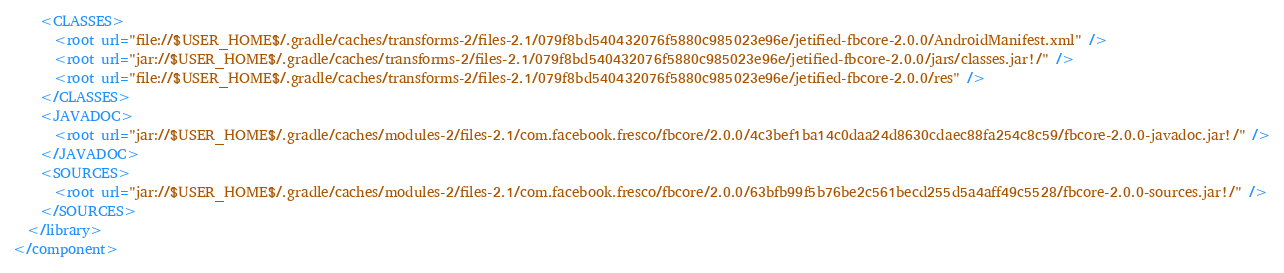Convert code to text. <code><loc_0><loc_0><loc_500><loc_500><_XML_>    <CLASSES>
      <root url="file://$USER_HOME$/.gradle/caches/transforms-2/files-2.1/079f8bd540432076f5880c985023e96e/jetified-fbcore-2.0.0/AndroidManifest.xml" />
      <root url="jar://$USER_HOME$/.gradle/caches/transforms-2/files-2.1/079f8bd540432076f5880c985023e96e/jetified-fbcore-2.0.0/jars/classes.jar!/" />
      <root url="file://$USER_HOME$/.gradle/caches/transforms-2/files-2.1/079f8bd540432076f5880c985023e96e/jetified-fbcore-2.0.0/res" />
    </CLASSES>
    <JAVADOC>
      <root url="jar://$USER_HOME$/.gradle/caches/modules-2/files-2.1/com.facebook.fresco/fbcore/2.0.0/4c3bef1ba14c0daa24d8630cdaec88fa254c8c59/fbcore-2.0.0-javadoc.jar!/" />
    </JAVADOC>
    <SOURCES>
      <root url="jar://$USER_HOME$/.gradle/caches/modules-2/files-2.1/com.facebook.fresco/fbcore/2.0.0/63bfb99f5b76be2c561becd255d5a4aff49c5528/fbcore-2.0.0-sources.jar!/" />
    </SOURCES>
  </library>
</component></code> 